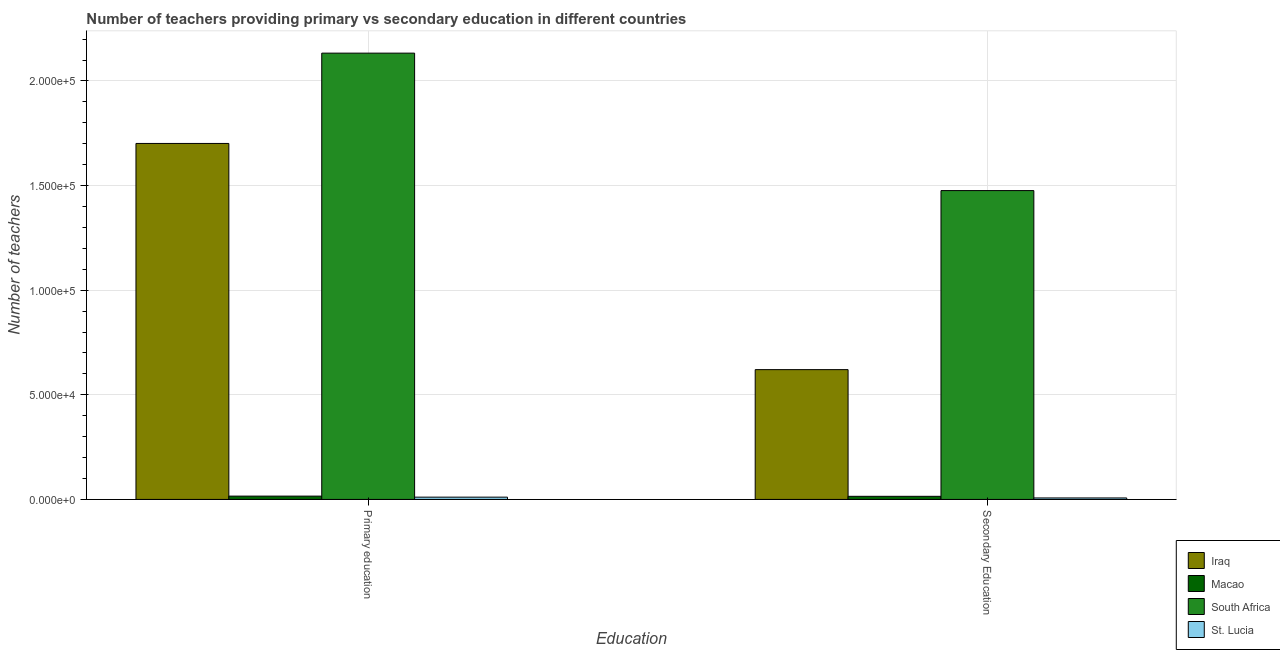Are the number of bars per tick equal to the number of legend labels?
Your response must be concise. Yes. Are the number of bars on each tick of the X-axis equal?
Your answer should be compact. Yes. How many bars are there on the 2nd tick from the right?
Provide a succinct answer. 4. What is the label of the 1st group of bars from the left?
Your response must be concise. Primary education. What is the number of primary teachers in Iraq?
Your answer should be compact. 1.70e+05. Across all countries, what is the maximum number of secondary teachers?
Give a very brief answer. 1.48e+05. Across all countries, what is the minimum number of primary teachers?
Offer a terse response. 1091. In which country was the number of primary teachers maximum?
Keep it short and to the point. South Africa. In which country was the number of secondary teachers minimum?
Your answer should be compact. St. Lucia. What is the total number of primary teachers in the graph?
Give a very brief answer. 3.86e+05. What is the difference between the number of secondary teachers in Iraq and that in St. Lucia?
Your answer should be compact. 6.13e+04. What is the difference between the number of primary teachers in Macao and the number of secondary teachers in St. Lucia?
Offer a very short reply. 873. What is the average number of primary teachers per country?
Offer a terse response. 9.65e+04. What is the difference between the number of secondary teachers and number of primary teachers in Iraq?
Your answer should be very brief. -1.08e+05. In how many countries, is the number of secondary teachers greater than 70000 ?
Keep it short and to the point. 1. What is the ratio of the number of primary teachers in Macao to that in St. Lucia?
Provide a short and direct response. 1.45. What does the 1st bar from the left in Secondary Education represents?
Offer a terse response. Iraq. What does the 3rd bar from the right in Secondary Education represents?
Keep it short and to the point. Macao. Are all the bars in the graph horizontal?
Your response must be concise. No. Are the values on the major ticks of Y-axis written in scientific E-notation?
Provide a short and direct response. Yes. Does the graph contain grids?
Provide a succinct answer. Yes. How many legend labels are there?
Ensure brevity in your answer.  4. How are the legend labels stacked?
Ensure brevity in your answer.  Vertical. What is the title of the graph?
Provide a succinct answer. Number of teachers providing primary vs secondary education in different countries. Does "Dominica" appear as one of the legend labels in the graph?
Ensure brevity in your answer.  No. What is the label or title of the X-axis?
Offer a very short reply. Education. What is the label or title of the Y-axis?
Provide a short and direct response. Number of teachers. What is the Number of teachers of Iraq in Primary education?
Keep it short and to the point. 1.70e+05. What is the Number of teachers in Macao in Primary education?
Provide a short and direct response. 1578. What is the Number of teachers in South Africa in Primary education?
Provide a succinct answer. 2.13e+05. What is the Number of teachers in St. Lucia in Primary education?
Offer a very short reply. 1091. What is the Number of teachers in Iraq in Secondary Education?
Keep it short and to the point. 6.20e+04. What is the Number of teachers of Macao in Secondary Education?
Offer a very short reply. 1481. What is the Number of teachers in South Africa in Secondary Education?
Your response must be concise. 1.48e+05. What is the Number of teachers in St. Lucia in Secondary Education?
Provide a succinct answer. 705. Across all Education, what is the maximum Number of teachers in Iraq?
Offer a very short reply. 1.70e+05. Across all Education, what is the maximum Number of teachers of Macao?
Offer a terse response. 1578. Across all Education, what is the maximum Number of teachers of South Africa?
Give a very brief answer. 2.13e+05. Across all Education, what is the maximum Number of teachers in St. Lucia?
Give a very brief answer. 1091. Across all Education, what is the minimum Number of teachers in Iraq?
Make the answer very short. 6.20e+04. Across all Education, what is the minimum Number of teachers in Macao?
Ensure brevity in your answer.  1481. Across all Education, what is the minimum Number of teachers in South Africa?
Ensure brevity in your answer.  1.48e+05. Across all Education, what is the minimum Number of teachers in St. Lucia?
Provide a succinct answer. 705. What is the total Number of teachers in Iraq in the graph?
Keep it short and to the point. 2.32e+05. What is the total Number of teachers in Macao in the graph?
Provide a succinct answer. 3059. What is the total Number of teachers of South Africa in the graph?
Give a very brief answer. 3.61e+05. What is the total Number of teachers in St. Lucia in the graph?
Keep it short and to the point. 1796. What is the difference between the Number of teachers in Iraq in Primary education and that in Secondary Education?
Your response must be concise. 1.08e+05. What is the difference between the Number of teachers of Macao in Primary education and that in Secondary Education?
Keep it short and to the point. 97. What is the difference between the Number of teachers in South Africa in Primary education and that in Secondary Education?
Your answer should be very brief. 6.57e+04. What is the difference between the Number of teachers of St. Lucia in Primary education and that in Secondary Education?
Your response must be concise. 386. What is the difference between the Number of teachers of Iraq in Primary education and the Number of teachers of Macao in Secondary Education?
Your answer should be compact. 1.69e+05. What is the difference between the Number of teachers of Iraq in Primary education and the Number of teachers of South Africa in Secondary Education?
Provide a short and direct response. 2.25e+04. What is the difference between the Number of teachers of Iraq in Primary education and the Number of teachers of St. Lucia in Secondary Education?
Your response must be concise. 1.69e+05. What is the difference between the Number of teachers in Macao in Primary education and the Number of teachers in South Africa in Secondary Education?
Give a very brief answer. -1.46e+05. What is the difference between the Number of teachers of Macao in Primary education and the Number of teachers of St. Lucia in Secondary Education?
Make the answer very short. 873. What is the difference between the Number of teachers in South Africa in Primary education and the Number of teachers in St. Lucia in Secondary Education?
Offer a terse response. 2.13e+05. What is the average Number of teachers in Iraq per Education?
Offer a terse response. 1.16e+05. What is the average Number of teachers in Macao per Education?
Provide a short and direct response. 1529.5. What is the average Number of teachers in South Africa per Education?
Ensure brevity in your answer.  1.80e+05. What is the average Number of teachers in St. Lucia per Education?
Your answer should be very brief. 898. What is the difference between the Number of teachers in Iraq and Number of teachers in Macao in Primary education?
Offer a very short reply. 1.69e+05. What is the difference between the Number of teachers in Iraq and Number of teachers in South Africa in Primary education?
Your response must be concise. -4.32e+04. What is the difference between the Number of teachers of Iraq and Number of teachers of St. Lucia in Primary education?
Offer a very short reply. 1.69e+05. What is the difference between the Number of teachers of Macao and Number of teachers of South Africa in Primary education?
Your response must be concise. -2.12e+05. What is the difference between the Number of teachers in Macao and Number of teachers in St. Lucia in Primary education?
Offer a terse response. 487. What is the difference between the Number of teachers of South Africa and Number of teachers of St. Lucia in Primary education?
Make the answer very short. 2.12e+05. What is the difference between the Number of teachers in Iraq and Number of teachers in Macao in Secondary Education?
Make the answer very short. 6.06e+04. What is the difference between the Number of teachers of Iraq and Number of teachers of South Africa in Secondary Education?
Your answer should be very brief. -8.56e+04. What is the difference between the Number of teachers in Iraq and Number of teachers in St. Lucia in Secondary Education?
Your answer should be very brief. 6.13e+04. What is the difference between the Number of teachers of Macao and Number of teachers of South Africa in Secondary Education?
Give a very brief answer. -1.46e+05. What is the difference between the Number of teachers of Macao and Number of teachers of St. Lucia in Secondary Education?
Provide a short and direct response. 776. What is the difference between the Number of teachers in South Africa and Number of teachers in St. Lucia in Secondary Education?
Provide a succinct answer. 1.47e+05. What is the ratio of the Number of teachers in Iraq in Primary education to that in Secondary Education?
Keep it short and to the point. 2.74. What is the ratio of the Number of teachers of Macao in Primary education to that in Secondary Education?
Your response must be concise. 1.07. What is the ratio of the Number of teachers in South Africa in Primary education to that in Secondary Education?
Make the answer very short. 1.45. What is the ratio of the Number of teachers of St. Lucia in Primary education to that in Secondary Education?
Your answer should be very brief. 1.55. What is the difference between the highest and the second highest Number of teachers in Iraq?
Your response must be concise. 1.08e+05. What is the difference between the highest and the second highest Number of teachers of Macao?
Ensure brevity in your answer.  97. What is the difference between the highest and the second highest Number of teachers of South Africa?
Your response must be concise. 6.57e+04. What is the difference between the highest and the second highest Number of teachers in St. Lucia?
Offer a very short reply. 386. What is the difference between the highest and the lowest Number of teachers in Iraq?
Your answer should be compact. 1.08e+05. What is the difference between the highest and the lowest Number of teachers in Macao?
Make the answer very short. 97. What is the difference between the highest and the lowest Number of teachers in South Africa?
Provide a short and direct response. 6.57e+04. What is the difference between the highest and the lowest Number of teachers of St. Lucia?
Your response must be concise. 386. 